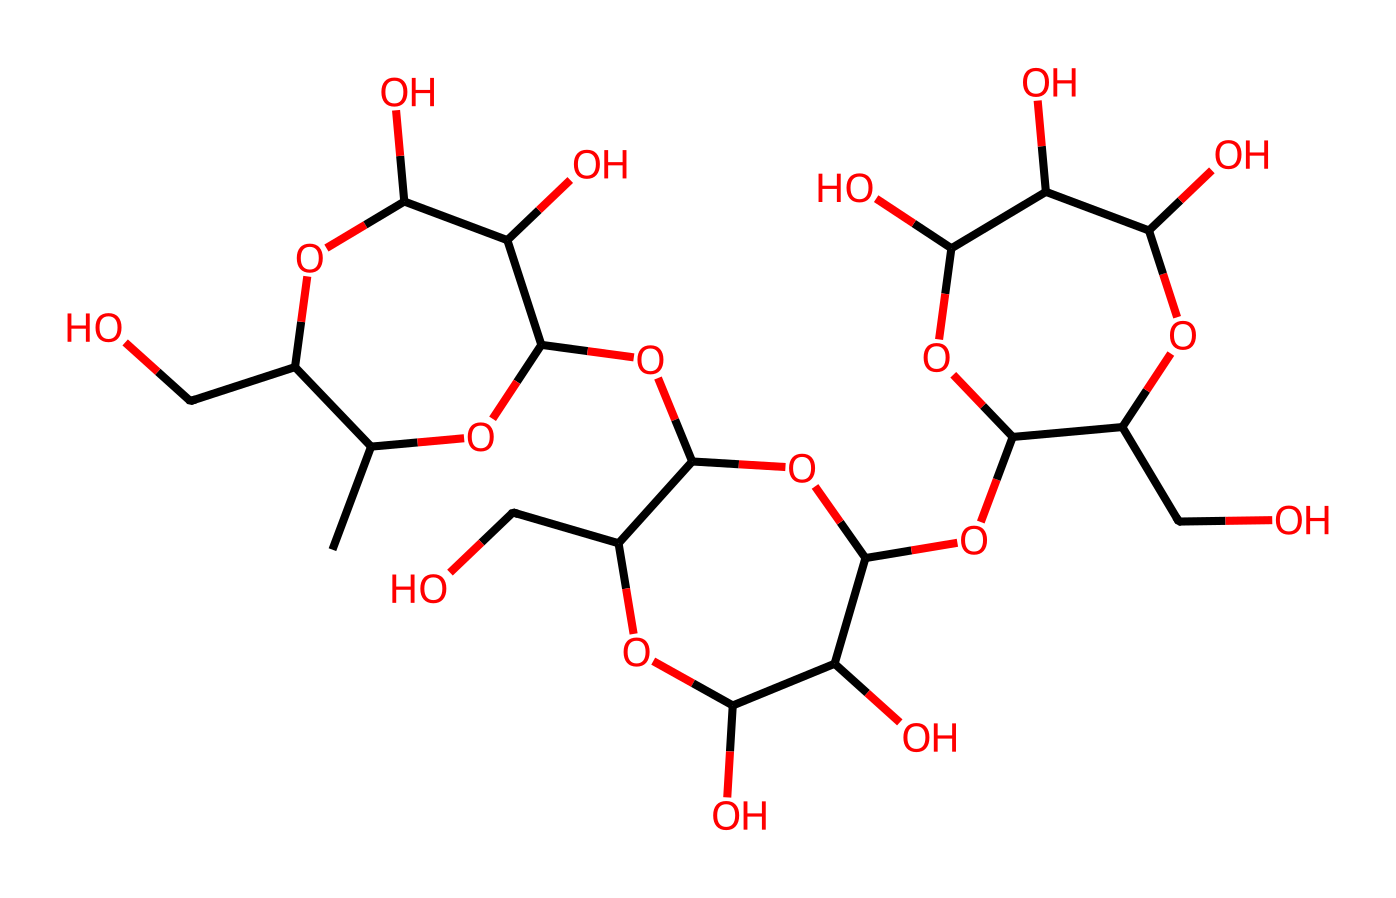What type of carbohydrate is represented by the SMILES? The SMILES structure corresponds to a polysaccharide, as it has multiple sugar units linked together. Specifically, glycogen is a branched polysaccharide and is known for its role in energy storage.
Answer: polysaccharide How many ring structures does this molecule contain? Looking at the SMILES representation, the brackets indicate ring closures. There are three cyclic structures indicated by 'O1', 'O2', and 'O3' in the arrangement, confirming that this molecule contains three ring structures.
Answer: three What is the main function of glycogen in animals? Glycogen primarily serves as a storage form of glucose, which can be quickly mobilized to meet energy demands in animals when required.
Answer: energy storage How many hydroxyl (-OH) groups are present in this molecule? Counting the 'O' atoms in the SMILES and analyzing where they are attached as hydroxyl groups, we find that there are a total of 15 -OH groups throughout the structure.
Answer: fifteen What type of linkage connects the glucose units in glycogen? The glucose units in glycogen are connected by alpha-1,4-glycosidic linkages for linear segments, and alpha-1,6-glycosidic linkages at branches. This relationship characterizes its structure and function.
Answer: alpha-1,4 and alpha-1,6 What is the effect of glycogen branching on glucose mobilization? The branching in glycogen increases the surface area for enzyme action, allowing for more rapid release of glucose when energy is needed, thereby enhancing mobilization efficiency.
Answer: faster mobilization 